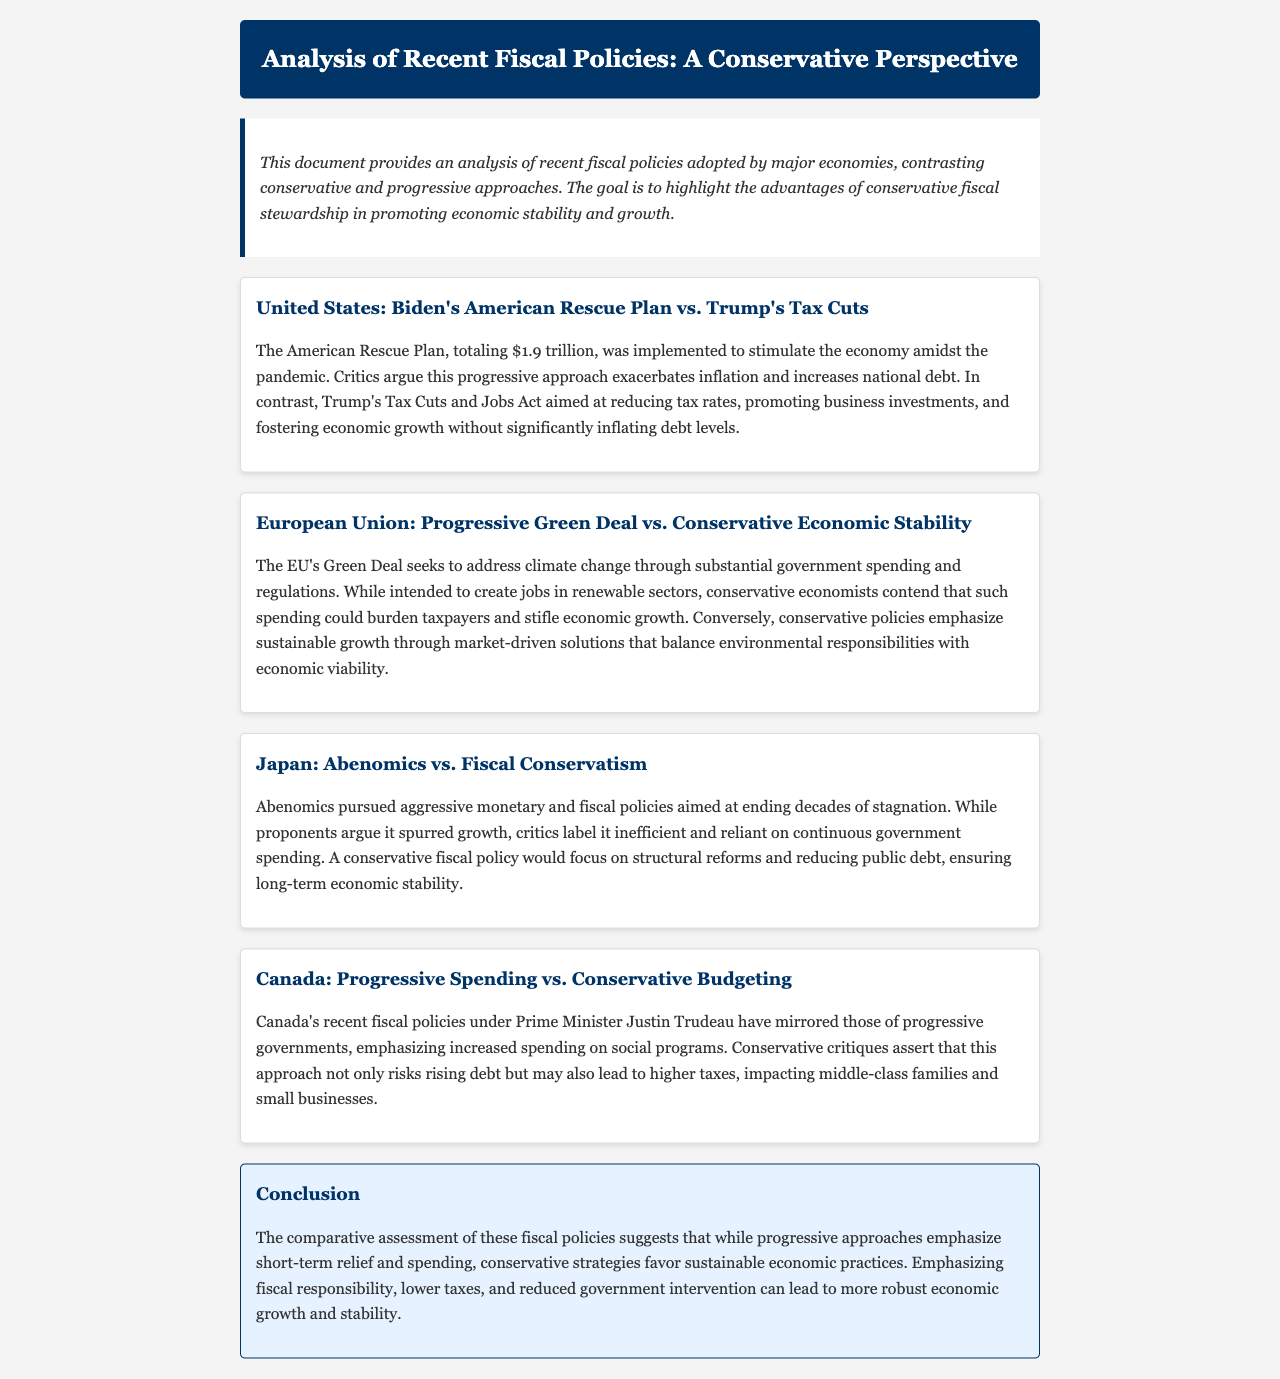What is the title of the document? The title of the document is presented in the header which summarizes the analysis perspective.
Answer: Analysis of Recent Fiscal Policies: A Conservative Perspective How much was Biden's American Rescue Plan? The document states the total amount of the plan to provide economic stimulus during the pandemic.
Answer: $1.9 trillion What economic strategy did Trump's Tax Cuts and Jobs Act aim to promote? The document explains the goal of Trump's Tax Cuts and Jobs Act in the context of economic growth.
Answer: Business investments What does the EU's Green Deal aim to address? The document describes the primary focus of the EU's Green Deal.
Answer: Climate change Which policy approach does Canada under Prime Minister Justin Trudeau represent? The passage discusses the nature of fiscal policies under Trudeau and indicates its direction.
Answer: Progressive Spending What is a criticism of Abenomics mentioned in the document? The document highlights a specific critique regarding the efficiency of Abenomics.
Answer: Inefficient What is emphasized by conservative policies according to the document? The passage reflects on core tenets of conservative fiscal strategies relative to market solutions.
Answer: Sustainable growth What do critics argue about the American Rescue Plan's impact? The document mentions specific consequences critics associate with the Rescue Plan.
Answer: Exacerbates inflation What is the conclusion regarding progressive and conservative fiscal policies? The conclusion outlines a comparative view on the effectiveness of the policies discussed.
Answer: Fiscal responsibility 